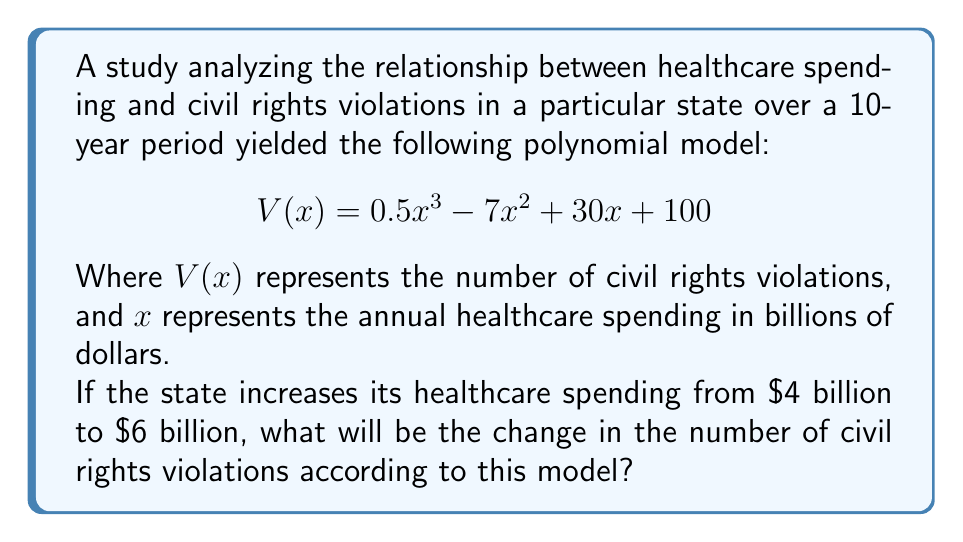Could you help me with this problem? To solve this problem, we need to calculate the difference between the number of civil rights violations at $6 billion and $4 billion of healthcare spending.

1. First, let's calculate $V(4)$:
   $$V(4) = 0.5(4^3) - 7(4^2) + 30(4) + 100$$
   $$= 0.5(64) - 7(16) + 120 + 100$$
   $$= 32 - 112 + 120 + 100$$
   $$= 140$$

2. Now, let's calculate $V(6)$:
   $$V(6) = 0.5(6^3) - 7(6^2) + 30(6) + 100$$
   $$= 0.5(216) - 7(36) + 180 + 100$$
   $$= 108 - 252 + 180 + 100$$
   $$= 136$$

3. To find the change in the number of civil rights violations, we subtract $V(4)$ from $V(6)$:
   $$\text{Change} = V(6) - V(4) = 136 - 140 = -4$$

The negative result indicates a decrease in the number of civil rights violations.
Answer: The change in the number of civil rights violations when healthcare spending increases from $4 billion to $6 billion is a decrease of 4 violations. 